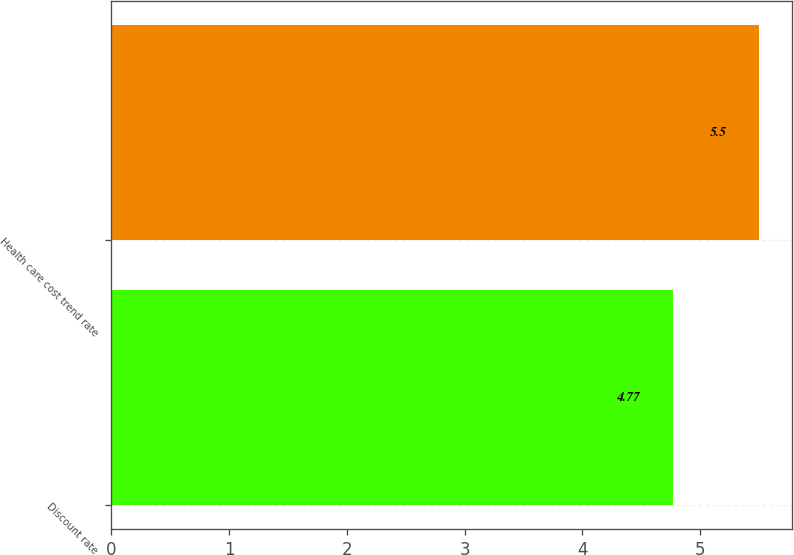Convert chart to OTSL. <chart><loc_0><loc_0><loc_500><loc_500><bar_chart><fcel>Discount rate<fcel>Health care cost trend rate<nl><fcel>4.77<fcel>5.5<nl></chart> 